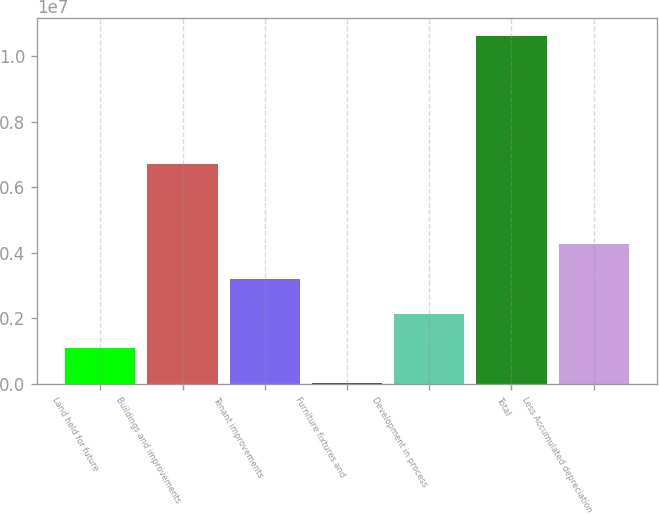Convert chart to OTSL. <chart><loc_0><loc_0><loc_500><loc_500><bar_chart><fcel>Land held for future<fcel>Buildings and improvements<fcel>Tenant improvements<fcel>Furniture fixtures and<fcel>Development in process<fcel>Total<fcel>Less Accumulated depreciation<nl><fcel>1.08247e+06<fcel>6.69832e+06<fcel>3.20155e+06<fcel>22929<fcel>2.14201e+06<fcel>1.06183e+07<fcel>4.2611e+06<nl></chart> 